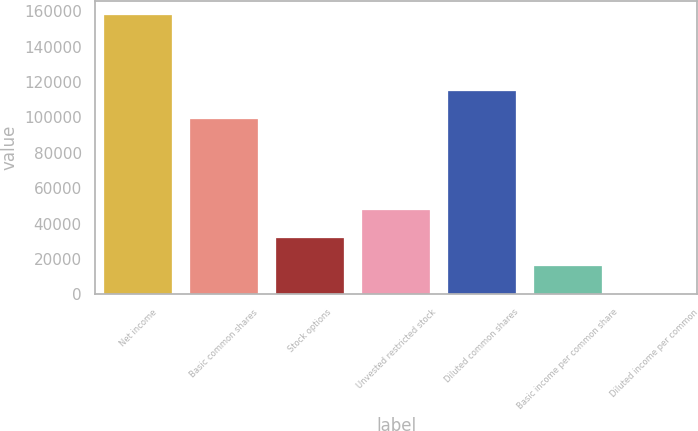<chart> <loc_0><loc_0><loc_500><loc_500><bar_chart><fcel>Net income<fcel>Basic common shares<fcel>Stock options<fcel>Unvested restricted stock<fcel>Diluted common shares<fcel>Basic income per common share<fcel>Diluted income per common<nl><fcel>158027<fcel>99281<fcel>31606.7<fcel>47409.2<fcel>115084<fcel>15804.1<fcel>1.57<nl></chart> 